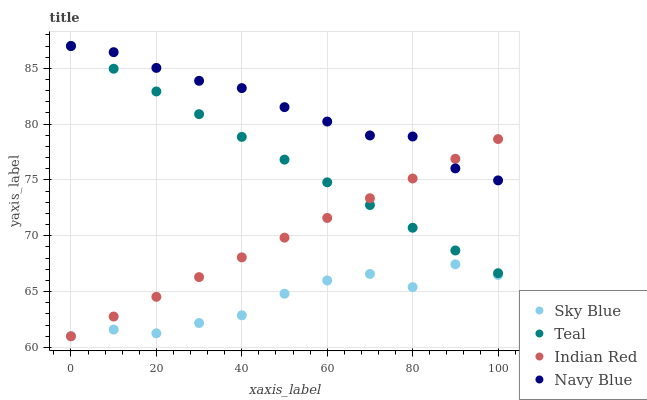Does Sky Blue have the minimum area under the curve?
Answer yes or no. Yes. Does Navy Blue have the maximum area under the curve?
Answer yes or no. Yes. Does Indian Red have the minimum area under the curve?
Answer yes or no. No. Does Indian Red have the maximum area under the curve?
Answer yes or no. No. Is Indian Red the smoothest?
Answer yes or no. Yes. Is Sky Blue the roughest?
Answer yes or no. Yes. Is Teal the smoothest?
Answer yes or no. No. Is Teal the roughest?
Answer yes or no. No. Does Sky Blue have the lowest value?
Answer yes or no. Yes. Does Teal have the lowest value?
Answer yes or no. No. Does Navy Blue have the highest value?
Answer yes or no. Yes. Does Indian Red have the highest value?
Answer yes or no. No. Is Sky Blue less than Navy Blue?
Answer yes or no. Yes. Is Navy Blue greater than Sky Blue?
Answer yes or no. Yes. Does Navy Blue intersect Indian Red?
Answer yes or no. Yes. Is Navy Blue less than Indian Red?
Answer yes or no. No. Is Navy Blue greater than Indian Red?
Answer yes or no. No. Does Sky Blue intersect Navy Blue?
Answer yes or no. No. 